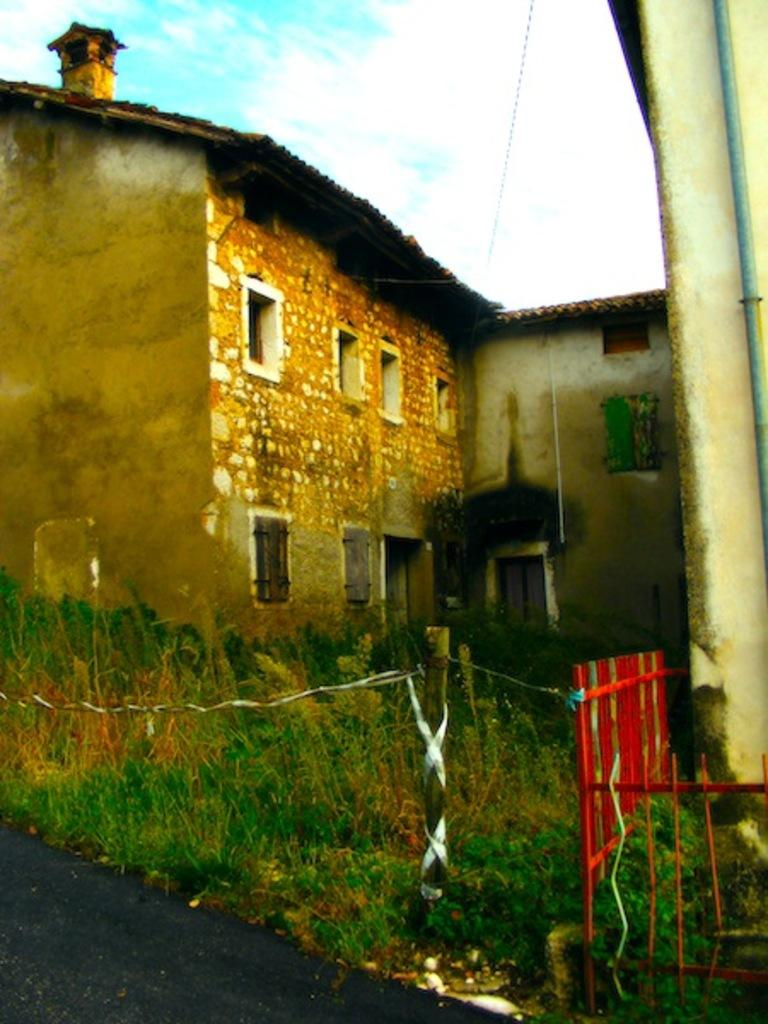What structure is visible in the image? There is a building in the image. What type of vegetation is present on the ground in the image? There are plants on the ground in the image. How would you describe the sky in the image? The sky is blue and cloudy in the image. What rule is being enforced by the bean in the image? There is no bean present in the image, and therefore no rule enforcement can be observed. What type of lipstick is the plant wearing in the image? There is no lipstick or plant wearing lipstick present in the image. 